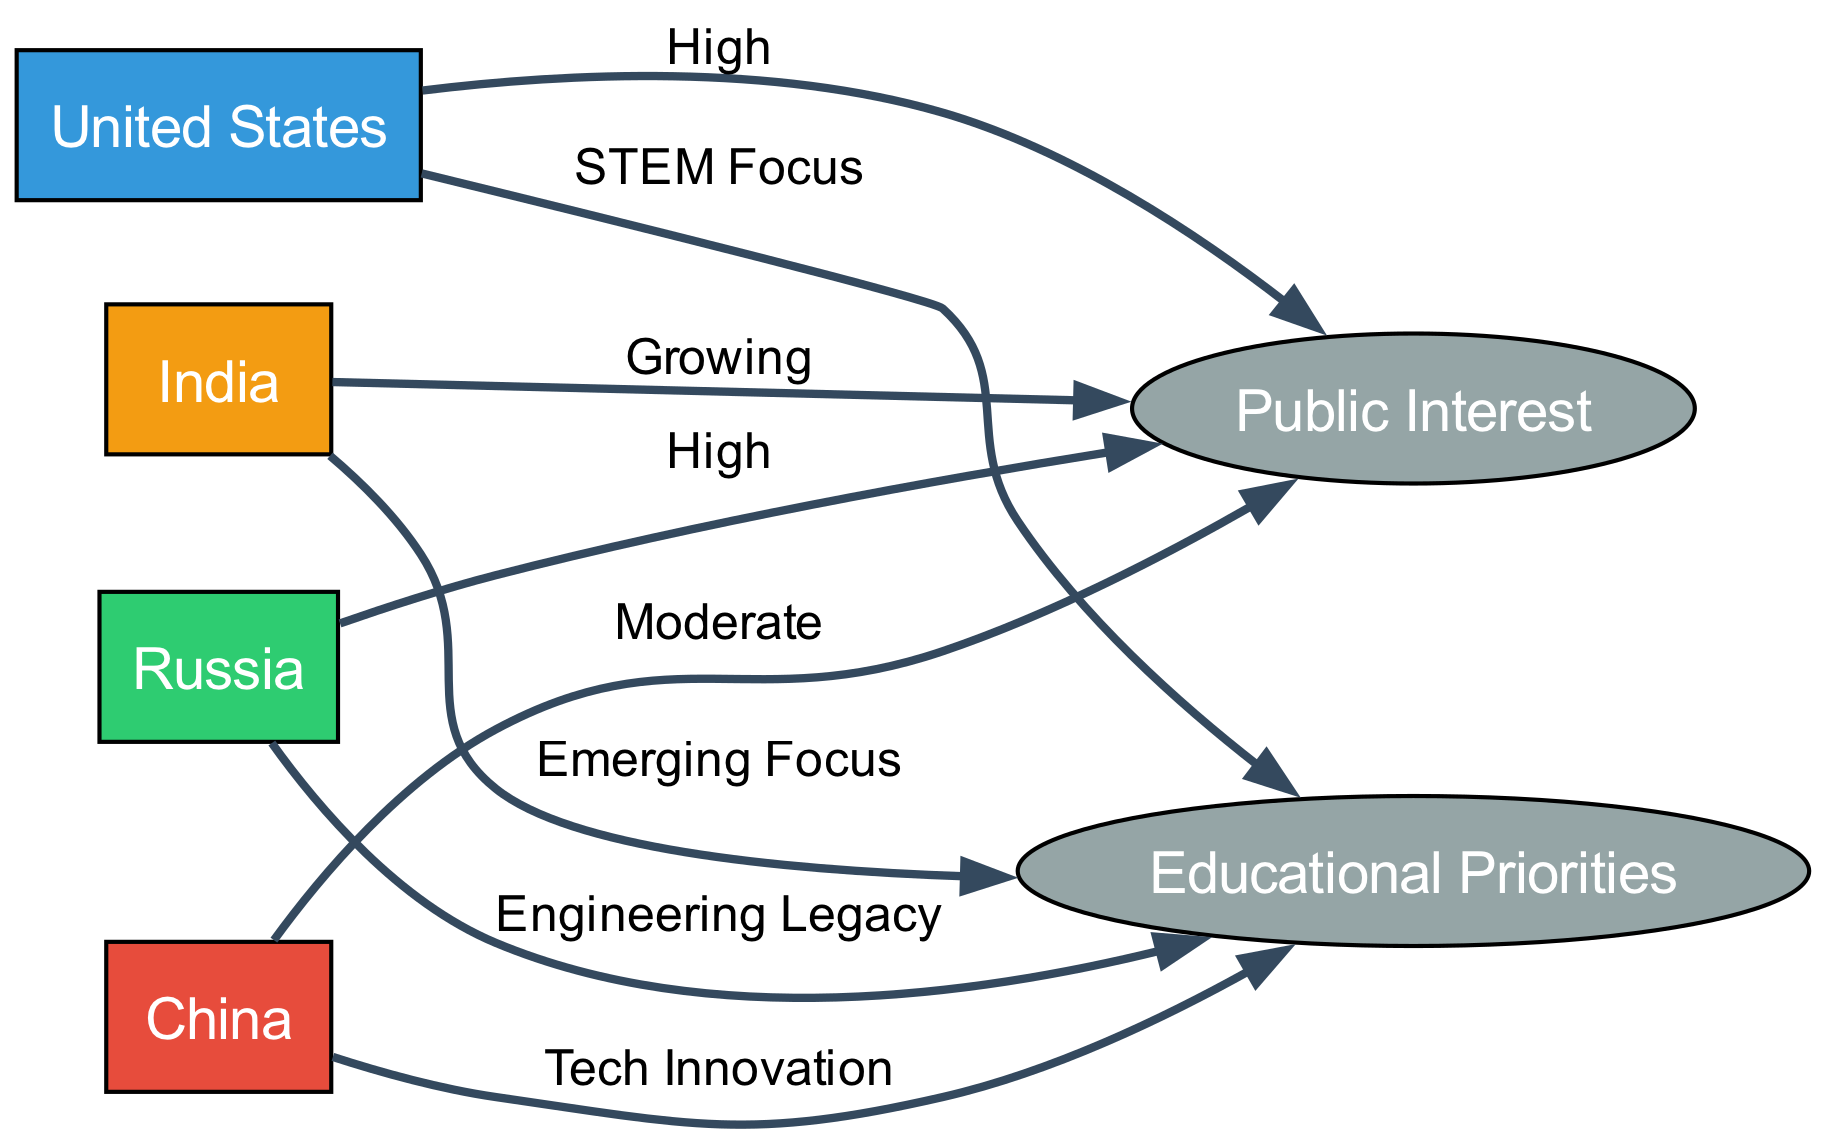What country shows high public interest in space exploration? The diagram indicates that both the United States and Russia have high public interest, as shown by the edges connecting these countries to the Public Interest node with the label "High."
Answer: United States, Russia What educational priority is linked to China? Observing the edges, China is connected to the Educational Priorities node with the label "Tech Innovation," indicating this specific educational focus.
Answer: Tech Innovation Which country has a growing public interest in space exploration? India is connected to the Public Interest node with the label "Growing," signifying its increasing interest level compared to others.
Answer: Growing How many total countries are represented in this diagram? The diagram has four countries listed as nodes: United States, China, Russia, and India, which gives us a total count of four.
Answer: 4 Which country is associated with STEM-focused educational priorities? The edge drawn from the United States to the Educational Priorities node is labeled "STEM Focus," making this connection clear.
Answer: United States What comparative interest does Russia display in the diagram? Russia is noted for demonstrating high public interest and has its educational priority labeled "Engineering Legacy," indicating a strong historical focus.
Answer: High Which country is linked to “Emerging Focus” priorities in education? The diagram indicates that India is connected to the Educational Priorities node with the label "Emerging Focus," highlighting its current educational emphasis.
Answer: Emerging Focus How does public interest in China compare to India according to the diagram? China has a moderate level of public interest connected to the Public Interest node, while India is classified as having a growing interest; this suggests a comparative increase for India.
Answer: Moderate, Growing What color represents India in the diagram? The diagram uses a specific color coding for each country, and India is represented in a shade of orange (#f39c12).
Answer: Orange 